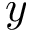Convert formula to latex. <formula><loc_0><loc_0><loc_500><loc_500>y</formula> 